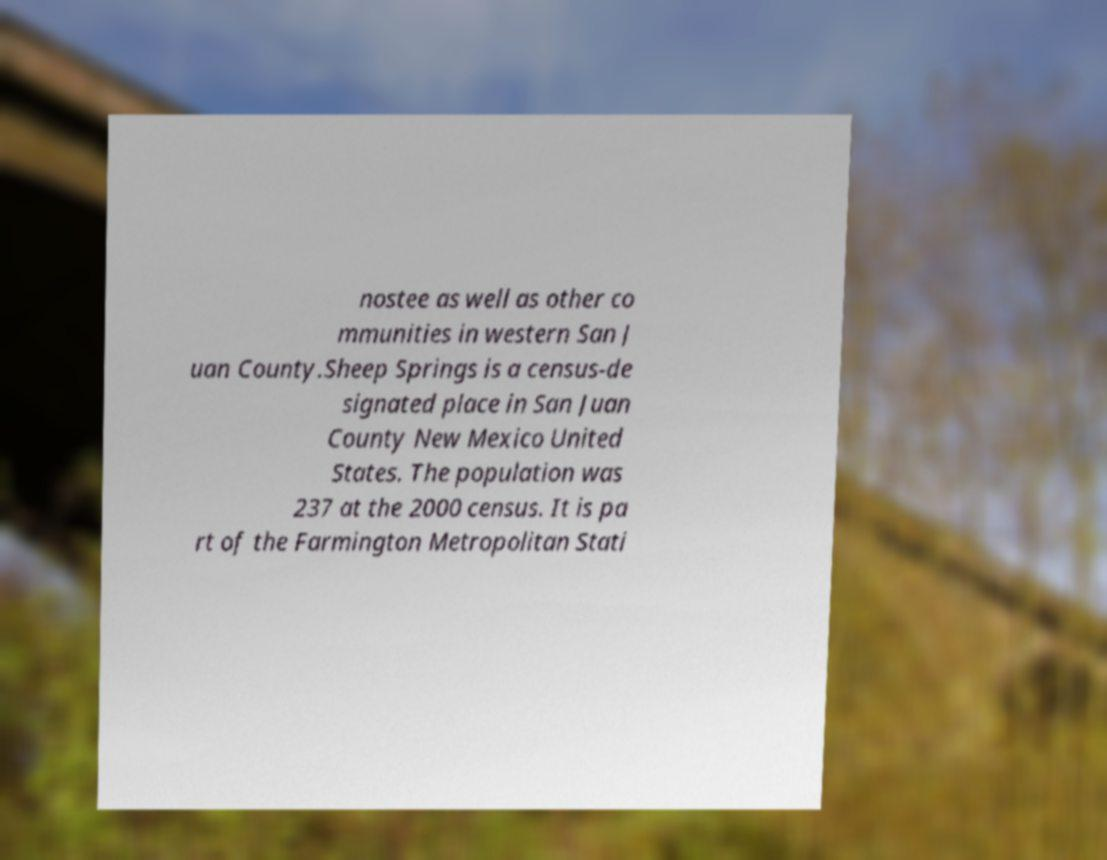Could you assist in decoding the text presented in this image and type it out clearly? nostee as well as other co mmunities in western San J uan County.Sheep Springs is a census-de signated place in San Juan County New Mexico United States. The population was 237 at the 2000 census. It is pa rt of the Farmington Metropolitan Stati 